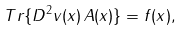Convert formula to latex. <formula><loc_0><loc_0><loc_500><loc_500>T r \{ D ^ { 2 } v ( x ) \, A ( x ) \} = f ( x ) ,</formula> 